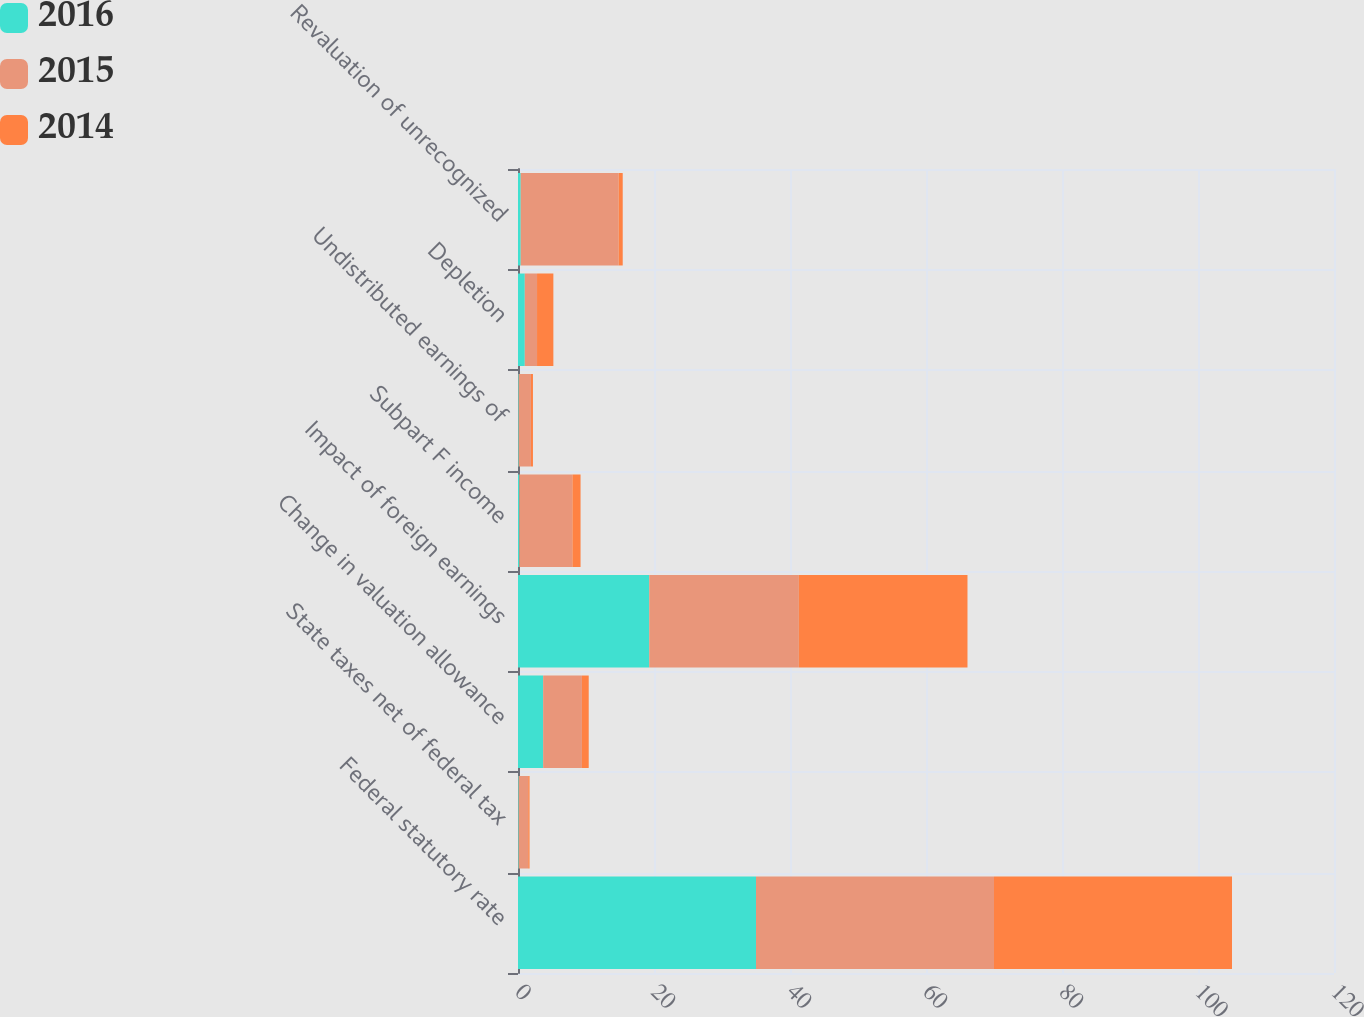<chart> <loc_0><loc_0><loc_500><loc_500><stacked_bar_chart><ecel><fcel>Federal statutory rate<fcel>State taxes net of federal tax<fcel>Change in valuation allowance<fcel>Impact of foreign earnings<fcel>Subpart F income<fcel>Undistributed earnings of<fcel>Depletion<fcel>Revaluation of unrecognized<nl><fcel>2016<fcel>35<fcel>0.1<fcel>3.7<fcel>19.3<fcel>0.2<fcel>0.1<fcel>1<fcel>0.4<nl><fcel>2015<fcel>35<fcel>1.4<fcel>5.7<fcel>22<fcel>7.8<fcel>1.8<fcel>1.8<fcel>14.4<nl><fcel>2014<fcel>35<fcel>0.2<fcel>1<fcel>24.8<fcel>1.2<fcel>0.3<fcel>2.4<fcel>0.6<nl></chart> 